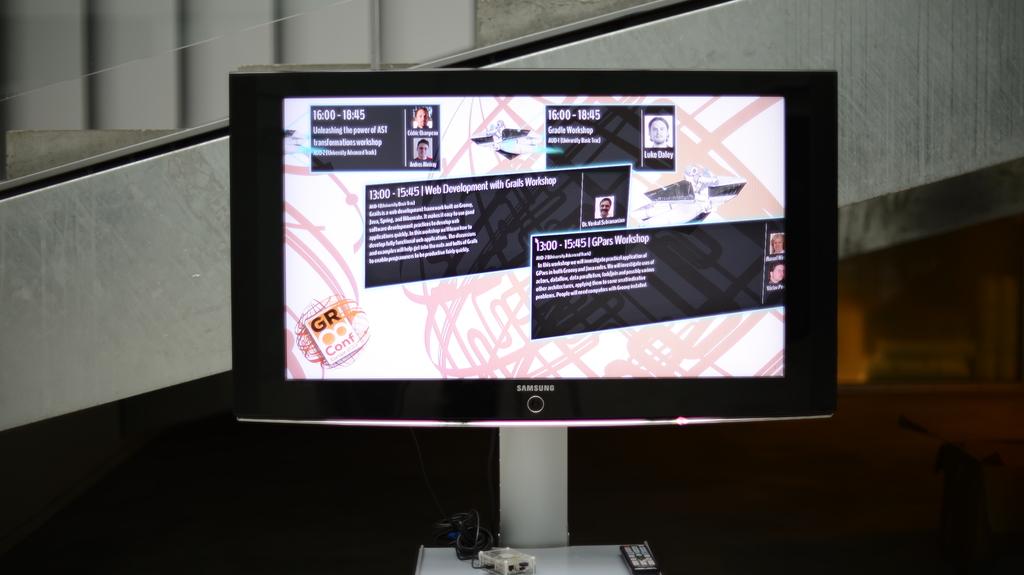What kind of work shop?
Your response must be concise. Gpars. 